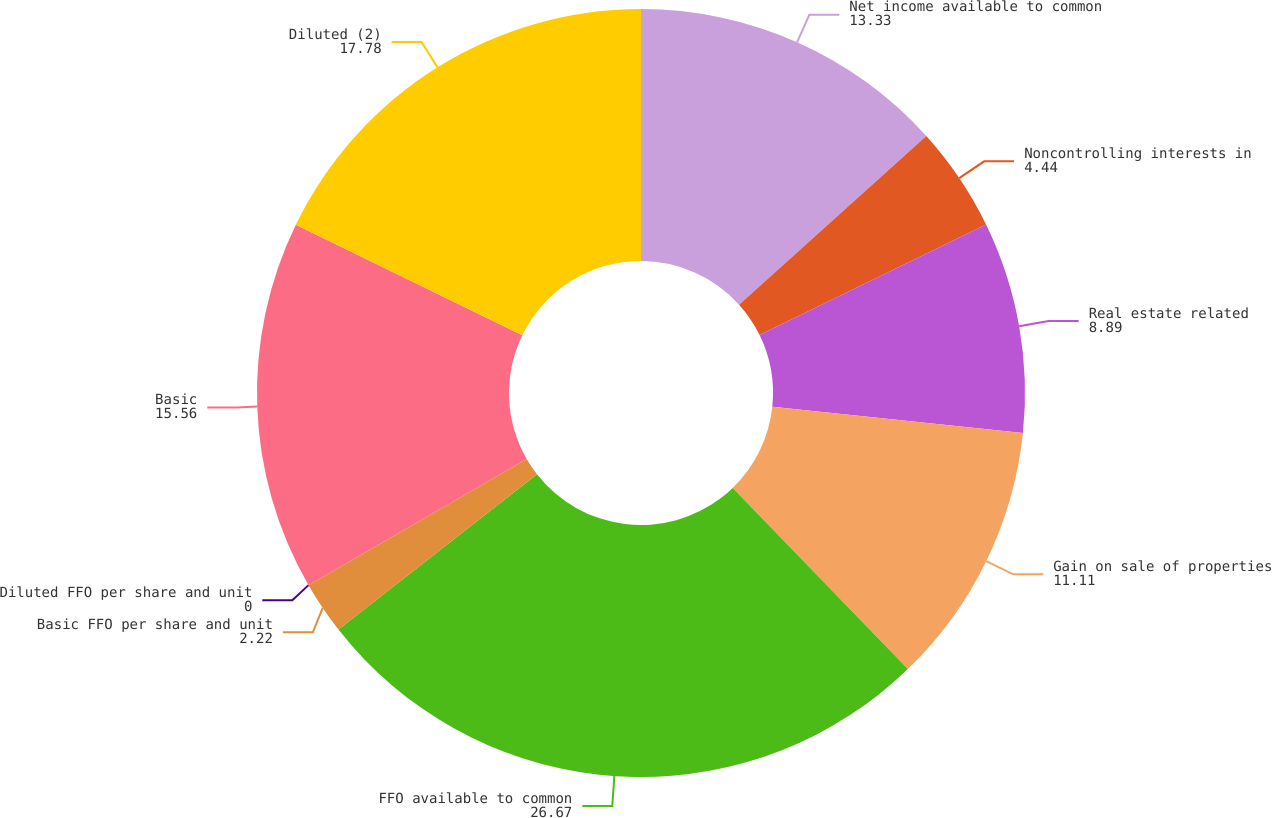Convert chart to OTSL. <chart><loc_0><loc_0><loc_500><loc_500><pie_chart><fcel>Net income available to common<fcel>Noncontrolling interests in<fcel>Real estate related<fcel>Gain on sale of properties<fcel>FFO available to common<fcel>Basic FFO per share and unit<fcel>Diluted FFO per share and unit<fcel>Basic<fcel>Diluted (2)<nl><fcel>13.33%<fcel>4.44%<fcel>8.89%<fcel>11.11%<fcel>26.67%<fcel>2.22%<fcel>0.0%<fcel>15.56%<fcel>17.78%<nl></chart> 